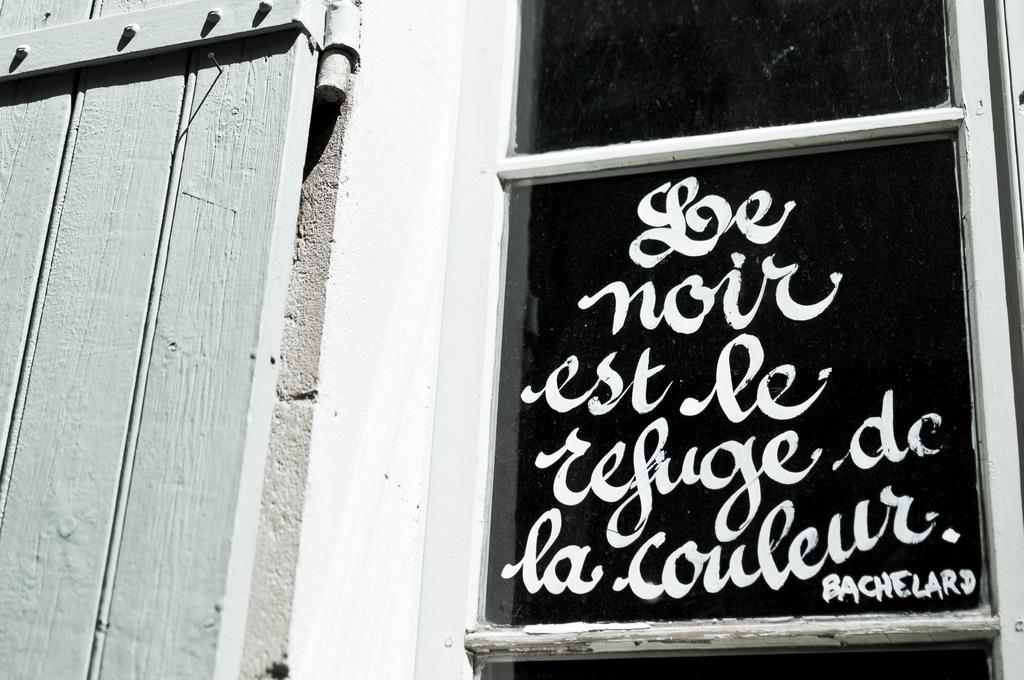What is written on in the image? There is text written on the glass of a window in the image. What type of door is located beside the window? There is a wooden door beside the window in the image. What color is the sweater worn by the carpenter in the image? There is no sweater or carpenter present in the image. What type of system is being used to write on the glass in the image? There is no system visible in the image; the text is simply written on the glass. 